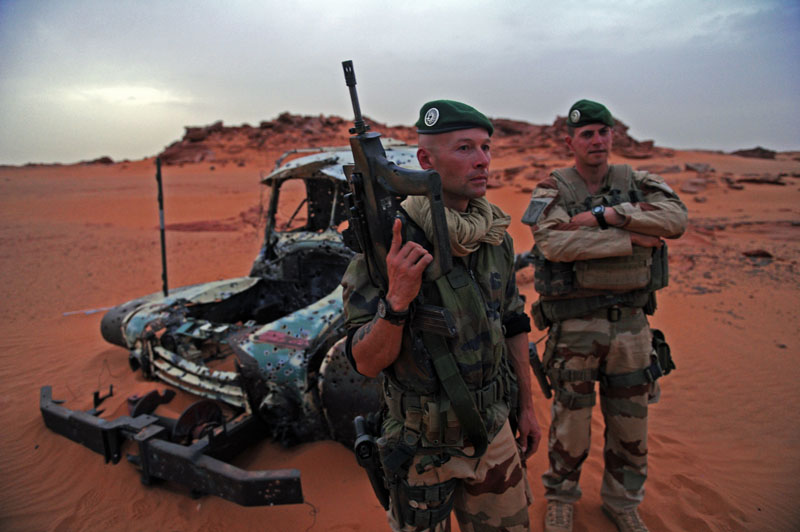Imagine the soldiers discover a hidden oasis. What actions might they take? Discovering an oasis would be a significant find for the soldiers. They would likely first secure the area to ensure it is safe from any hidden dangers or enemy presence. Once secured, they would set up a temporary camp to make use of the water supply, rehydrating and replenishing their water reserves. They might also take the opportunity to rest and recover from the harsh conditions. The presence of water might allow them to clean themselves and their equipment, reducing the impact of sand on their gear. Additionally, they might use the vegetation for shade and as a source of food if any edible plants or animals are present. What if the oasis is a mirage? If the oasis turned out to be a mirage, the soldiers would face acute disappointment and further stress. It would be critical for them to remain calm and redirect their efforts towards their original plans for finding water and shelter. They would need to conserve their remaining resources even more carefully and continue navigating with caution. The incident might also reinforce the importance of verifying visual cues in the desert and cross-referencing with their navigation tools to avoid such mistakes in the future. 